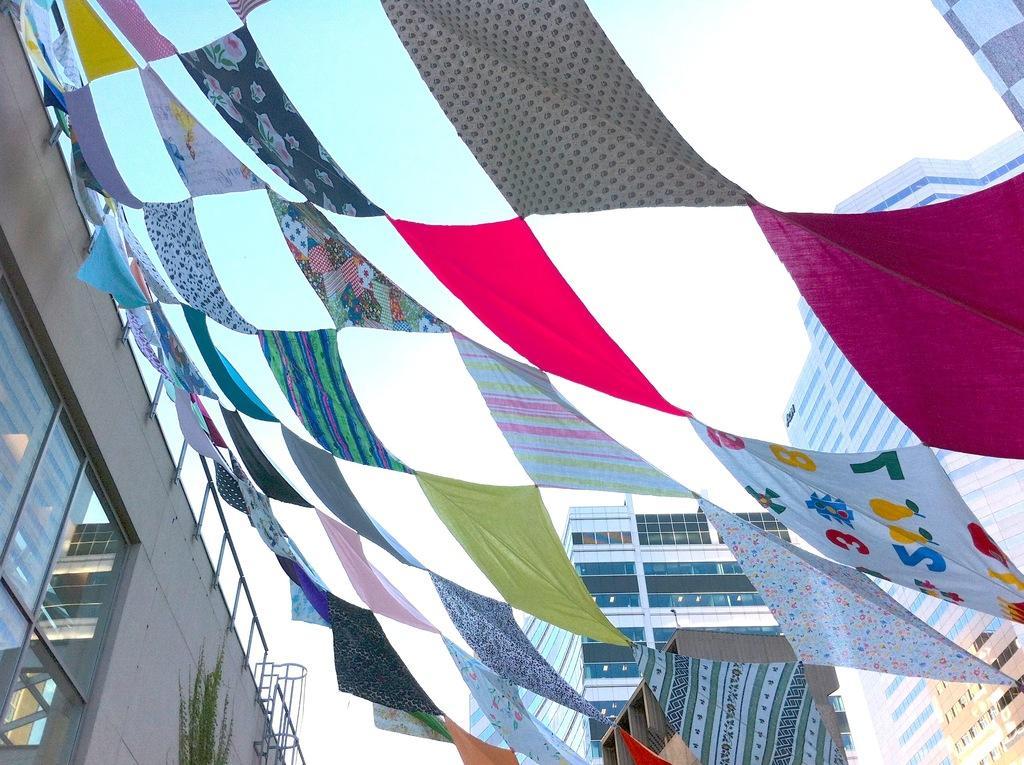Describe this image in one or two sentences. In this image I can see a building on the left side and there are few clothes attached to the fence of the building and in the middle I can see the sky 